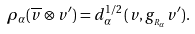Convert formula to latex. <formula><loc_0><loc_0><loc_500><loc_500>\rho _ { \alpha } ( \overline { v } \otimes v ^ { \prime } ) = d _ { \alpha } ^ { 1 / 2 } \, ( v , g _ { _ { R _ { \alpha } } } v ^ { \prime } ) .</formula> 